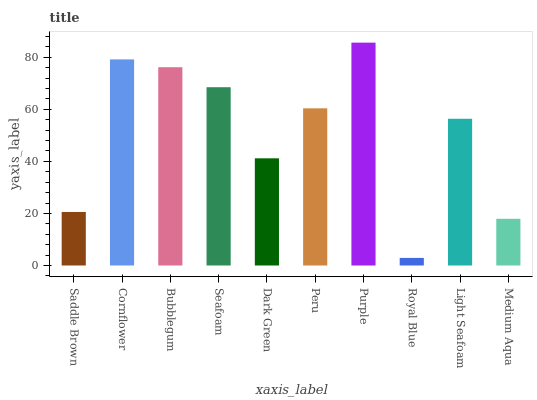Is Royal Blue the minimum?
Answer yes or no. Yes. Is Purple the maximum?
Answer yes or no. Yes. Is Cornflower the minimum?
Answer yes or no. No. Is Cornflower the maximum?
Answer yes or no. No. Is Cornflower greater than Saddle Brown?
Answer yes or no. Yes. Is Saddle Brown less than Cornflower?
Answer yes or no. Yes. Is Saddle Brown greater than Cornflower?
Answer yes or no. No. Is Cornflower less than Saddle Brown?
Answer yes or no. No. Is Peru the high median?
Answer yes or no. Yes. Is Light Seafoam the low median?
Answer yes or no. Yes. Is Light Seafoam the high median?
Answer yes or no. No. Is Royal Blue the low median?
Answer yes or no. No. 